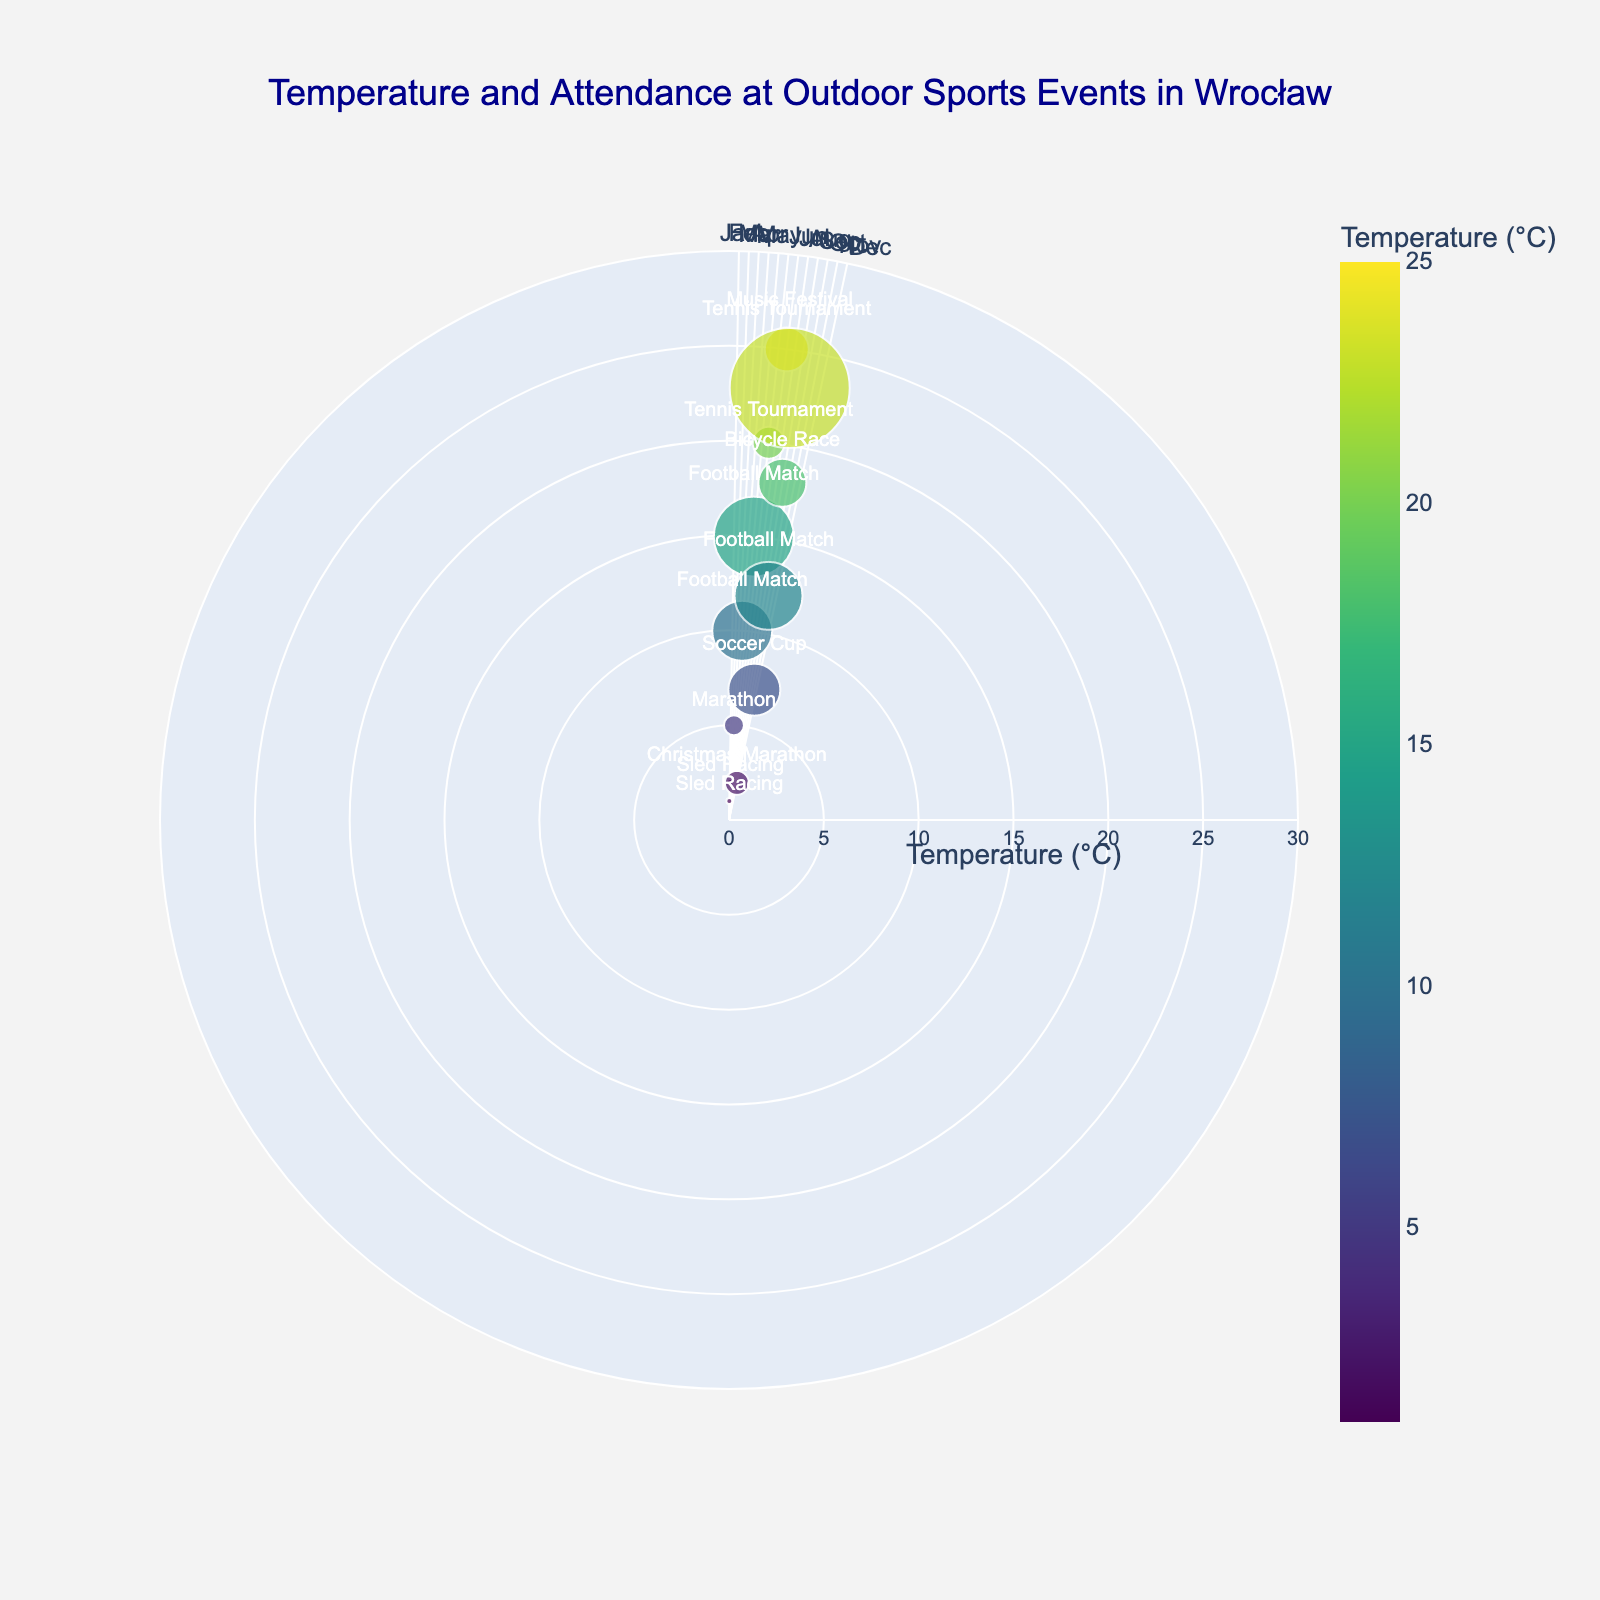What is the title of the chart? The title can be found at the top of the chart. It provides a brief summary of what the chart is about.
Answer: Temperature and Attendance at Outdoor Sports Events in Wrocław What color scale is used to represent the temperature? The color scale is indicated by the color gradient used in the markers.
Answer: Viridis Which month has the highest attendance and what event was it? Look for the largest marker indicating the highest attendance and refer to the associated text label. August has the highest attendance.
Answer: Music Festival in August Which event occurs in April and what is its attendance? Find the month labeled "Apr" on the angular axis, then check the marker and text label for that month.
Answer: Football Match with 1500 in attendance What is the average temperature for events in summer (June, July, August)? Sum the temperatures for June, July, and August, then divide by the number of months. (20 + 25 + 23) / 3 = 68 / 3
Answer: 22.67°C Which month has the lowest temperature and what event occurs then? Locate the marker at the smallest radial distance from the center, check the associated month and text.
Answer: January with Sled Racing Compare the attendance for Football Matches in April and October. Which one is higher and by how much? Find the markers for April and October, check the attendance values, and calculate the difference. 1700 (October) - 1500 (April)
Answer: October is higher by 200 How does the attendance for the Tennis Tournament change from June to July? Compare the sizes of the markers for June and July and check the attendance values. It increases from 800 to 1100.
Answer: It increases by 300 What is the range of temperatures depicted in this chart? Identify the minimum and maximum radial values representing temperature. The temperatures range from 1°C in January to 25°C in July.
Answer: From 1°C to 25°C Which month and event are represented by the marker with an attendance of 1200? Find the marker with an attendance value of 1200 using the hover information and text label.
Answer: September with the Bicycle Race 